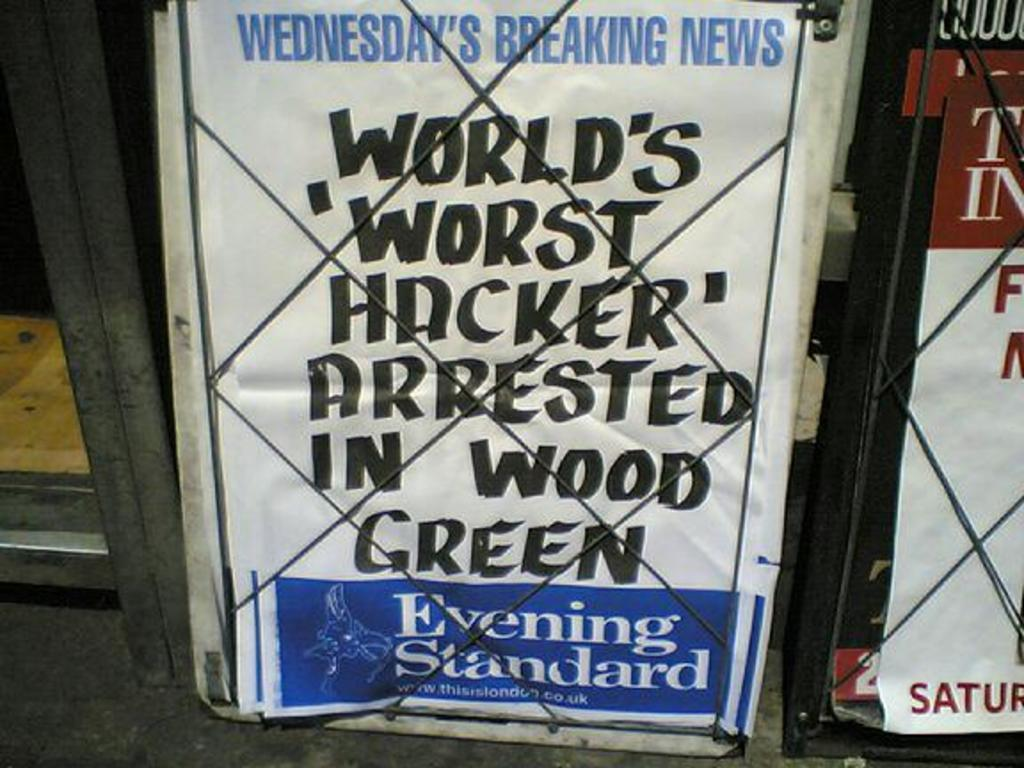<image>
Give a short and clear explanation of the subsequent image. Sign behind a fence that is about Wednesday's Breaking News. 